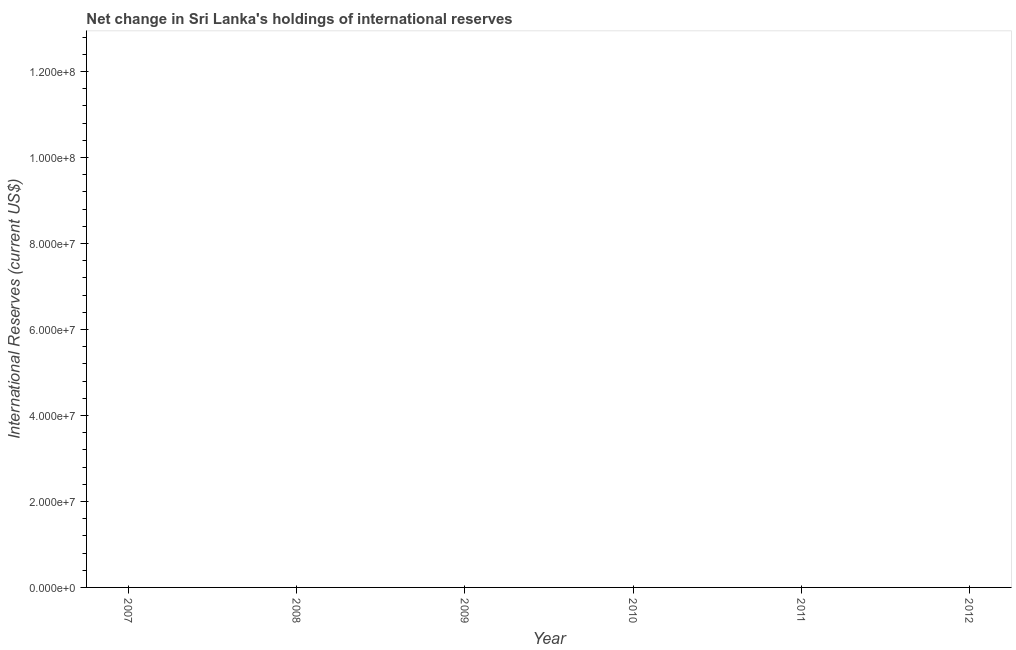Across all years, what is the minimum reserves and related items?
Offer a very short reply. 0. What is the sum of the reserves and related items?
Make the answer very short. 0. What is the average reserves and related items per year?
Offer a terse response. 0. What is the median reserves and related items?
Offer a terse response. 0. In how many years, is the reserves and related items greater than 44000000 US$?
Your answer should be compact. 0. In how many years, is the reserves and related items greater than the average reserves and related items taken over all years?
Your answer should be very brief. 0. How many lines are there?
Give a very brief answer. 0. Are the values on the major ticks of Y-axis written in scientific E-notation?
Offer a terse response. Yes. What is the title of the graph?
Provide a short and direct response. Net change in Sri Lanka's holdings of international reserves. What is the label or title of the X-axis?
Ensure brevity in your answer.  Year. What is the label or title of the Y-axis?
Your answer should be compact. International Reserves (current US$). What is the International Reserves (current US$) of 2008?
Offer a terse response. 0. What is the International Reserves (current US$) of 2011?
Provide a succinct answer. 0. 